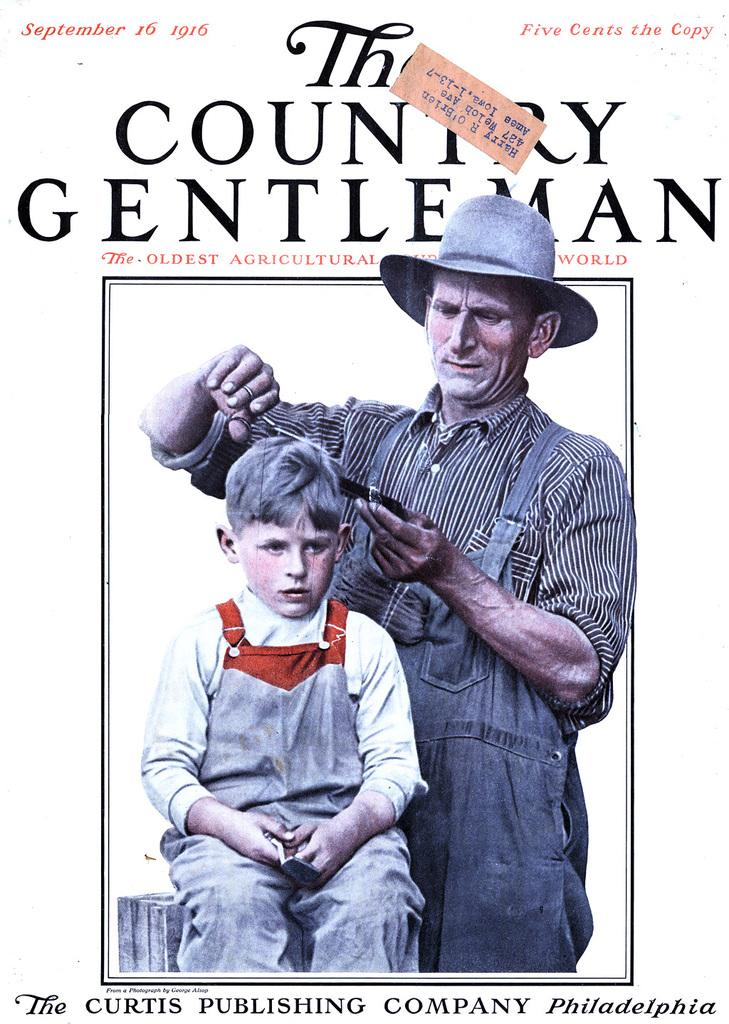What is present in the image? There is a poster in the image. What can be seen in the center of the poster? The poster has an image in the center that depicts a man cutting a boy's hair. Are there any words on the poster? Yes, there is text written on the poster. How many giraffes are visible in the image? There are no giraffes present in the image; the image depicts a man cutting a boy's hair. 